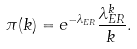<formula> <loc_0><loc_0><loc_500><loc_500>\pi ( k ) = e ^ { - \lambda _ { E R } } \frac { \lambda _ { E R } ^ { k } } { k \, } .</formula> 